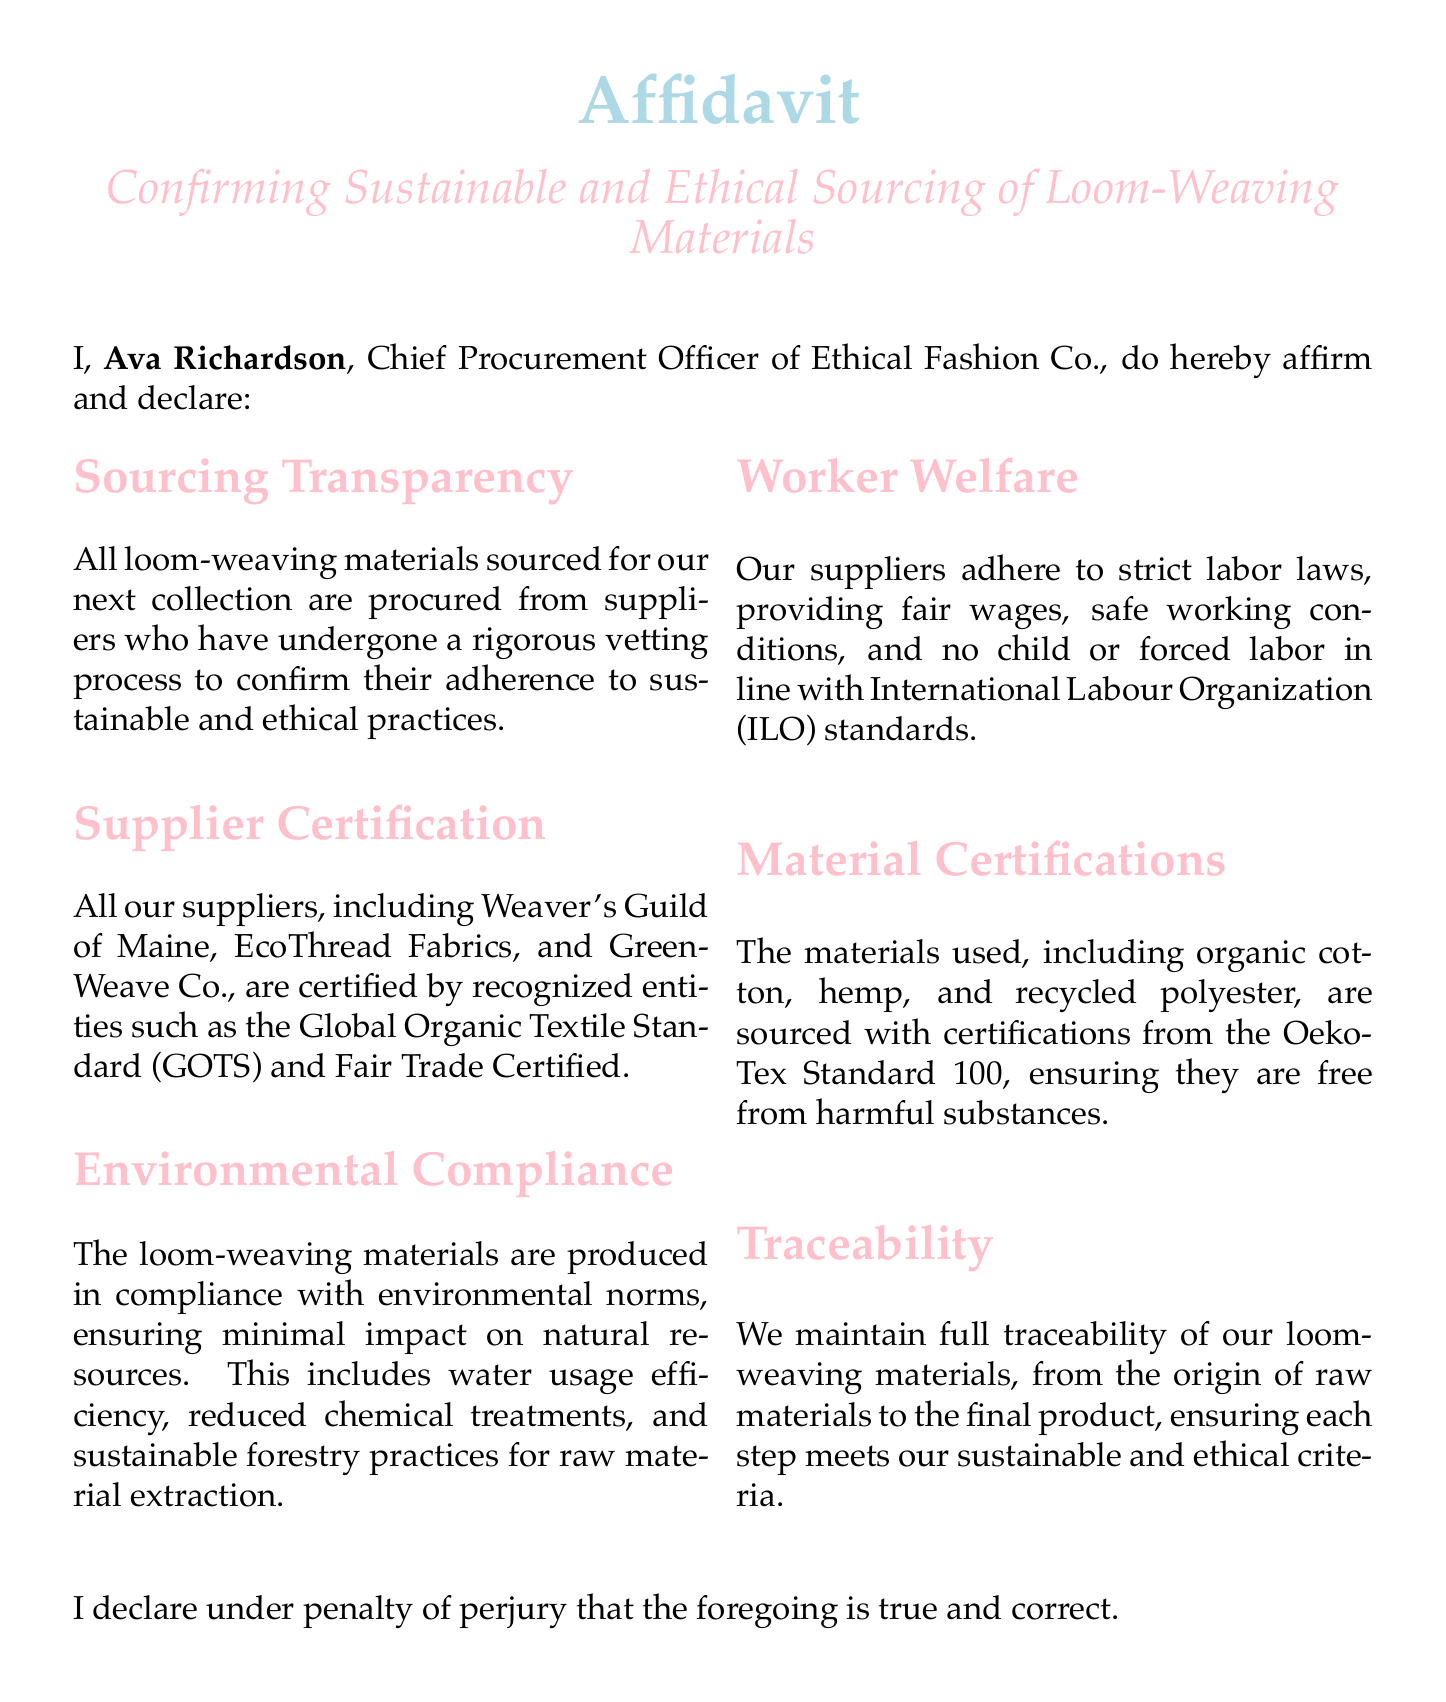What is the name of the Chief Procurement Officer? The document states that the Chief Procurement Officer's name is Ava Richardson.
Answer: Ava Richardson Which company is mentioned in the affidavit? The affidavit confirms that the company involved is Ethical Fashion Co.
Answer: Ethical Fashion Co What date is the affidavit signed? The affidavit was signed on October 15, 2023, as indicated in the document.
Answer: October 15, 2023 Which certification is mentioned for the loom-weaving materials? One of the certifications mentioned for the materials is Oeko-Tex Standard 100.
Answer: Oeko-Tex Standard 100 What materials are included in sourcing? The affidavit states that the materials include organic cotton, hemp, and recycled polyester.
Answer: organic cotton, hemp, and recycled polyester What standard is referenced for worker welfare? The document refers to the International Labour Organization (ILO) standards concerning worker welfare.
Answer: International Labour Organization (ILO) How many suppliers are explicitly named? The affidavit mentions three suppliers by name.
Answer: three What is emphasized in the 'Sourcing Transparency' section? The 'Sourcing Transparency' section emphasizes that all materials are from suppliers adhering to sustainable and ethical practices.
Answer: sustainable and ethical practices Is child labor permitted according to the affidavit? The affidavit clearly states that child labor is not permitted under any circumstances per their supplier's adherence to labor laws.
Answer: No 